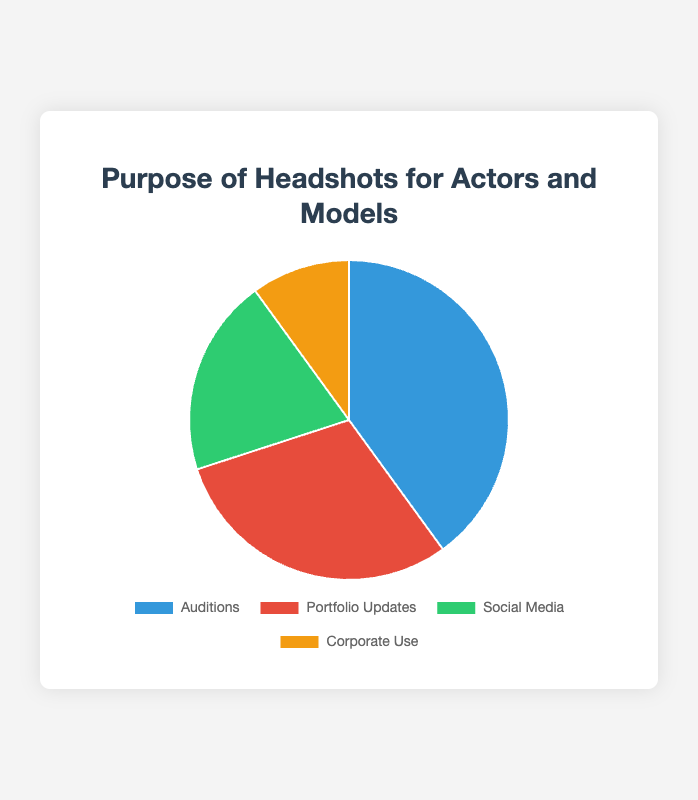What percentage of headshots are for auditions and portfolio updates combined? To find the combined percentage for auditions and portfolio updates, add their individual percentages: 40% (Auditions) + 30% (Portfolio Updates) = 70%.
Answer: 70% Which purpose has the smallest percentage of headshots? By looking at the pie chart, the smallest percentage corresponds to Corporate Use, which accounts for 10% of the headshots.
Answer: Corporate Use How much larger is the percentage of headshots for auditions compared to social media use? Calculate the difference between the percentages for auditions and social media: 40% (Auditions) - 20% (Social Media) = 20%.
Answer: 20% What is the combined percentage for social media and corporate use? Add the percentages of social media and corporate use: 20% (Social Media) + 10% (Corporate Use) = 30%.
Answer: 30% Which two purposes have the most similar percentages? Comparing the percentages directly, Portfolio Updates (30%) and Social Media (20%) are the closest to each other, with a difference of only 10%.
Answer: Portfolio Updates and Social Media How many times greater is the percentage of auditions compared to corporate use? Divide the percentage for auditions by the percentage for corporate use: 40% (Auditions) / 10% (Corporate Use) = 4.
Answer: 4 times Identify the purpose represented by the red section of the pie chart. The pie chart uses colors to represent different purposes. The red section represents Portfolio Updates.
Answer: Portfolio Updates Which purpose occupies the largest section of the pie chart? The largest section of the pie chart is the one representing auditions with 40%.
Answer: Auditions If the percentages for social media and corporate use were switched, how much would the combined percentage for social media and corporate use change? The combined original percentage is 20% (Social Media) + 10% (Corporate Use) = 30%. After switching, it would be 10% (Social Media) + 20% (Corporate Use) = 30%. The combined percentage remains the same.
Answer: 0% How does the percentage of headshots for portfolio updates compare to the percentage for social media? The percentage for portfolio updates (30%) is 10% higher than the percentage for social media (20%).
Answer: 10% higher 